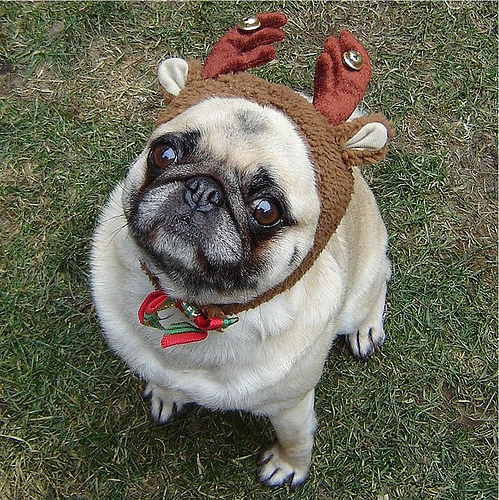<image>
Is there a antlers on the dog? Yes. Looking at the image, I can see the antlers is positioned on top of the dog, with the dog providing support. 